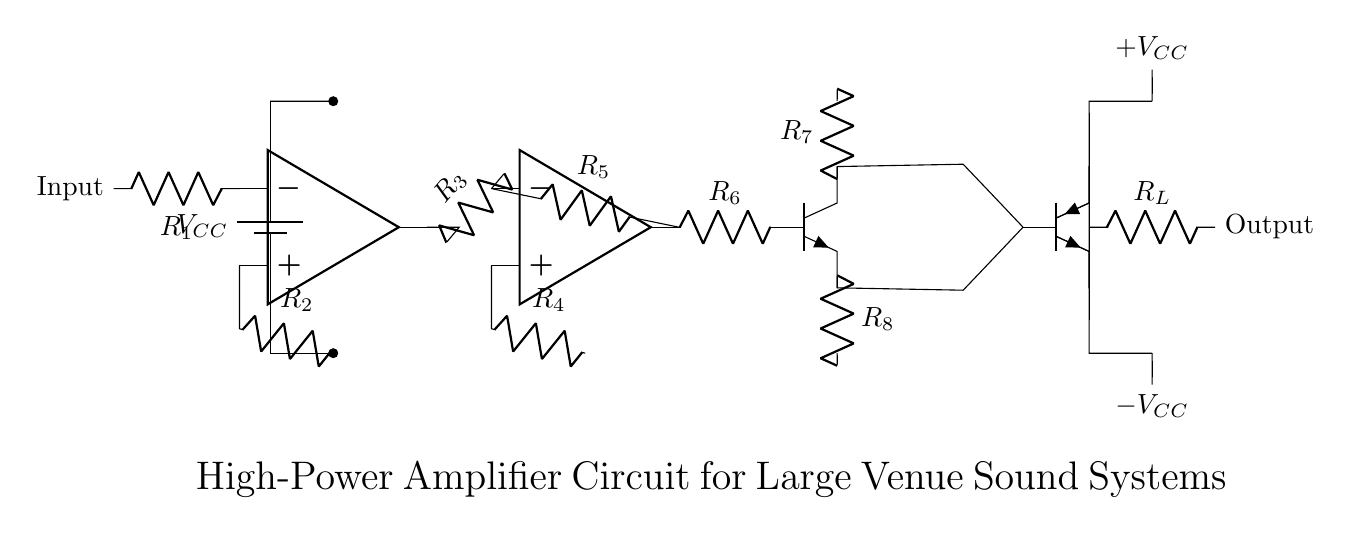What is the input component of the circuit? The input component is a resistor labeled as R1, which connects to the non-inverting input of the first operational amplifier.
Answer: R1 What are the two types of amplifiers present in the circuit? The circuit contains a voltage amplifier represented by the second operational amplifier and a current amplifier represented by the bipolar junction transistor (npn).
Answer: Voltage and current What is the output stage comprised of? The output stage consists of two transistors (one npn and one pnp) that work together to amplify the signal before it reaches the load resistor labeled R_L.
Answer: Two transistors What is the role of resistor R6 in the circuit? Resistor R6 connects the output of the voltage amplifier to the base of the current amplifier, controlling the amount of current fed into the current amplifier stage.
Answer: Base current control How does R_L affect the output of the amplifier circuit? Resistor R_L is the load resistor, which determines how much power is delivered to the connected speaker or sound system, affecting the audible volume and clarity of sound.
Answer: Load resistor effect What is V_CC referred to in the circuit? V_CC represents the supply voltage which powers the entire amplifier circuit, providing the necessary energy for amplification.
Answer: Supply voltage 